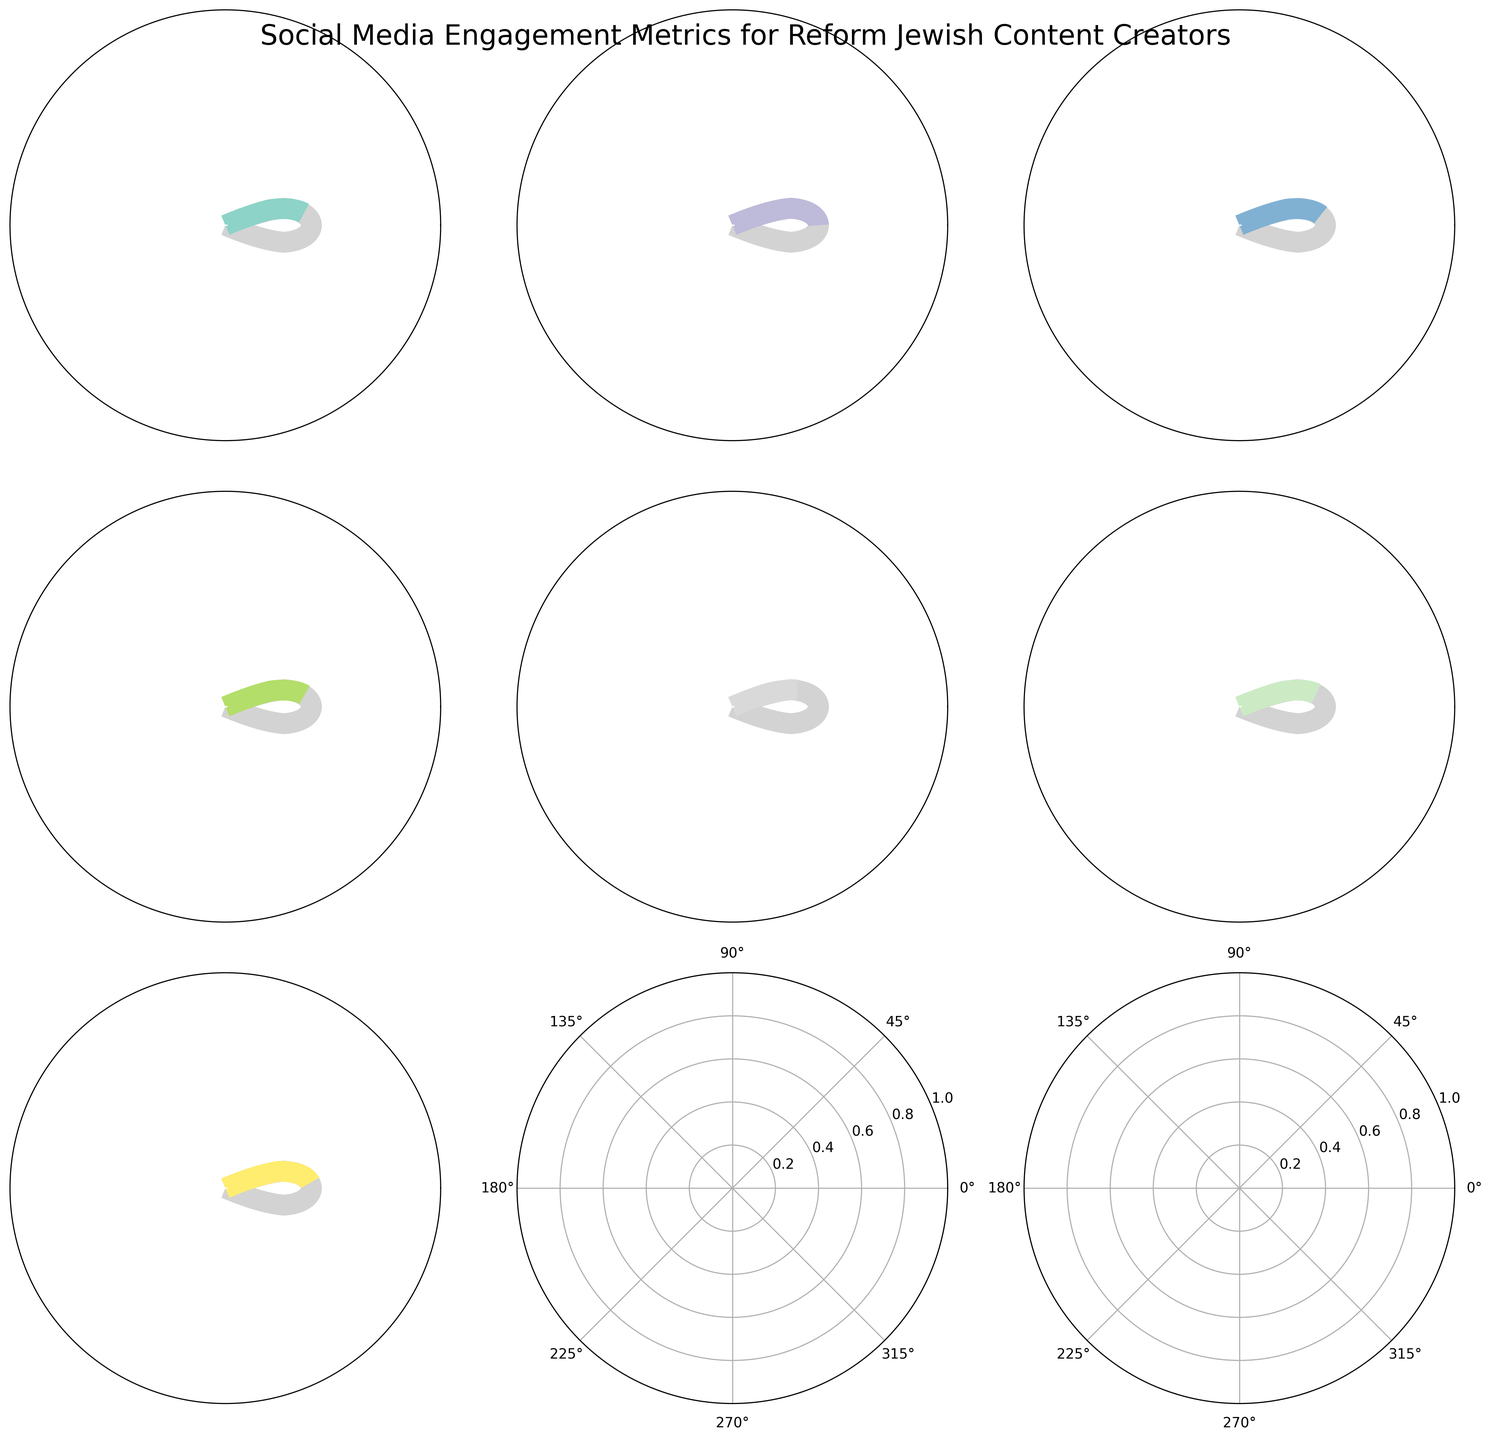What is the title of the figure? The title is the text at the top center of the figure
Answer: Social Media Engagement Metrics for Reform Jewish Content Creators How many metrics are displayed in the figure? By counting the number of gauge charts in the figure
Answer: 7 Which metric shows the highest value relative to its maximum? By comparing the relative positions of the needles on each gauge chart
Answer: Instagram Followers What is the exact value for the Facebook Post Engagement Rate in percentage? Look at the text value displayed below the needle in the gauge chart for Facebook Post Engagement Rate
Answer: 3.8% Which metric has the lowest maximum value? Look at the maximum values labeled on each gauge chart and compare them
Answer: LinkedIn Article Shares How does the current value of YouTube Subscriber Growth compare to its maximum? The needle points at 12% whereas the maximum is 30%, meaning it's less than half.
Answer: Less than half Which social media metric has the widest gauge, indicating the highest maximum value? By comparing the width of all gauges labeled with their maximum values
Answer: Pinterest Monthly Views What is the sum of the values for Pinterest Monthly Views and Twitter Retweets? Adding the values for Pinterest Monthly Views (180,000) and Twitter Retweets (85)
Answer: 180,085 Which metric indicates a relative need for improvement, given its value and maximum? By observing which needle points closer to the minimum value on its gauge chart
Answer: Facebook Post Engagement Rate Among all metrics, which one is exactly at the midpoint between its minimum and maximum values? Identify the gauge chart where the needle is positioned at the midpoint angle between its minimum and maximum values
Answer: TikTok Video Views 